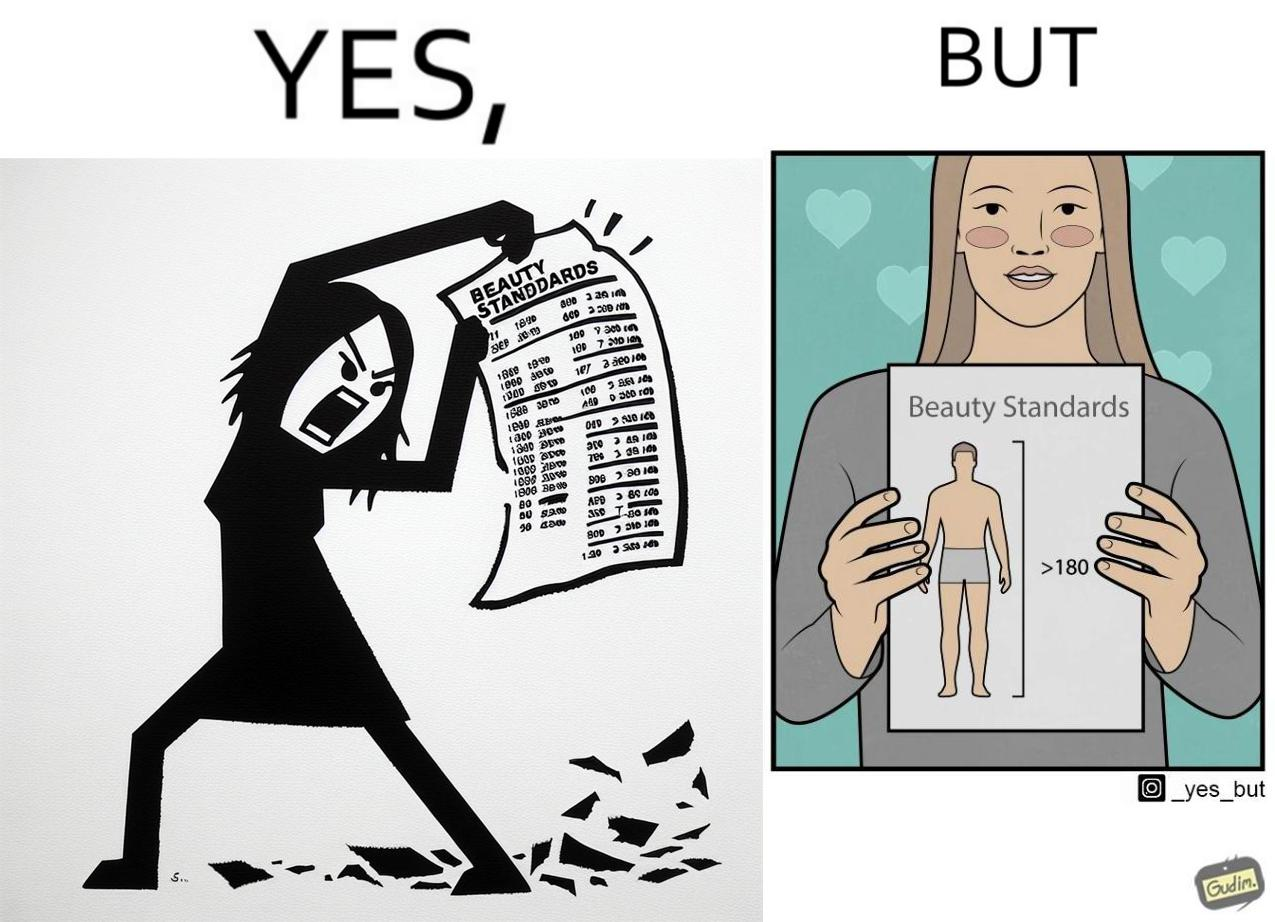Describe the satirical element in this image. The image is ironic because the woman that is angry about having constraints set on the body parts of a woman to be considered beautiful is the same person who is happily presenting contraints on the height of a man to be considered beautiful. 